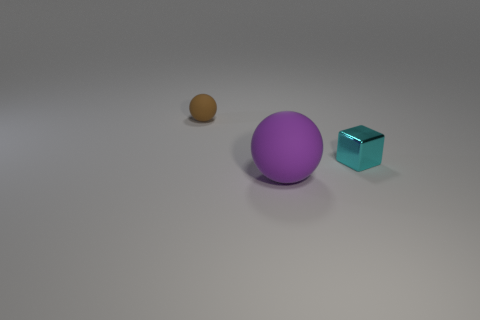Is there any other thing that is the same size as the purple rubber ball?
Give a very brief answer. No. Are there any other things that have the same material as the tiny cyan object?
Offer a very short reply. No. Is the size of the rubber ball that is in front of the brown object the same as the thing that is behind the tiny cyan cube?
Your response must be concise. No. There is a tiny object behind the shiny object; what shape is it?
Provide a succinct answer. Sphere. What is the material of the tiny brown thing that is the same shape as the big purple thing?
Your answer should be compact. Rubber. There is a sphere that is in front of the metallic thing; is it the same size as the cyan metallic object?
Provide a succinct answer. No. What number of tiny brown matte things are left of the brown rubber ball?
Your response must be concise. 0. Is the number of tiny brown spheres that are to the right of the tiny shiny thing less than the number of small cyan cubes to the right of the purple matte sphere?
Give a very brief answer. Yes. What number of things are there?
Provide a short and direct response. 3. There is a matte object behind the tiny cyan shiny object; what is its color?
Your answer should be compact. Brown. 